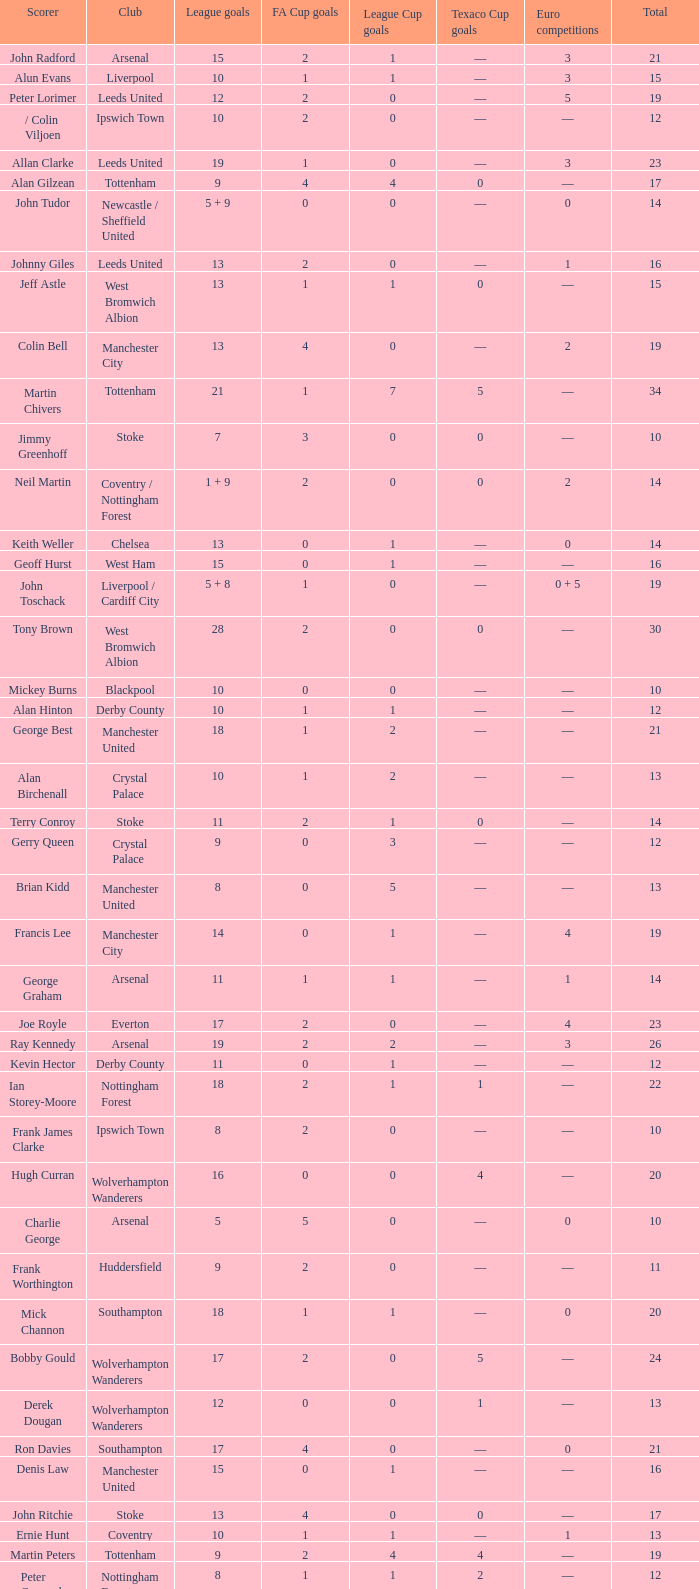What is the average Total, when FA Cup Goals is 1, when League Goals is 10, and when Club is Crystal Palace? 13.0. 